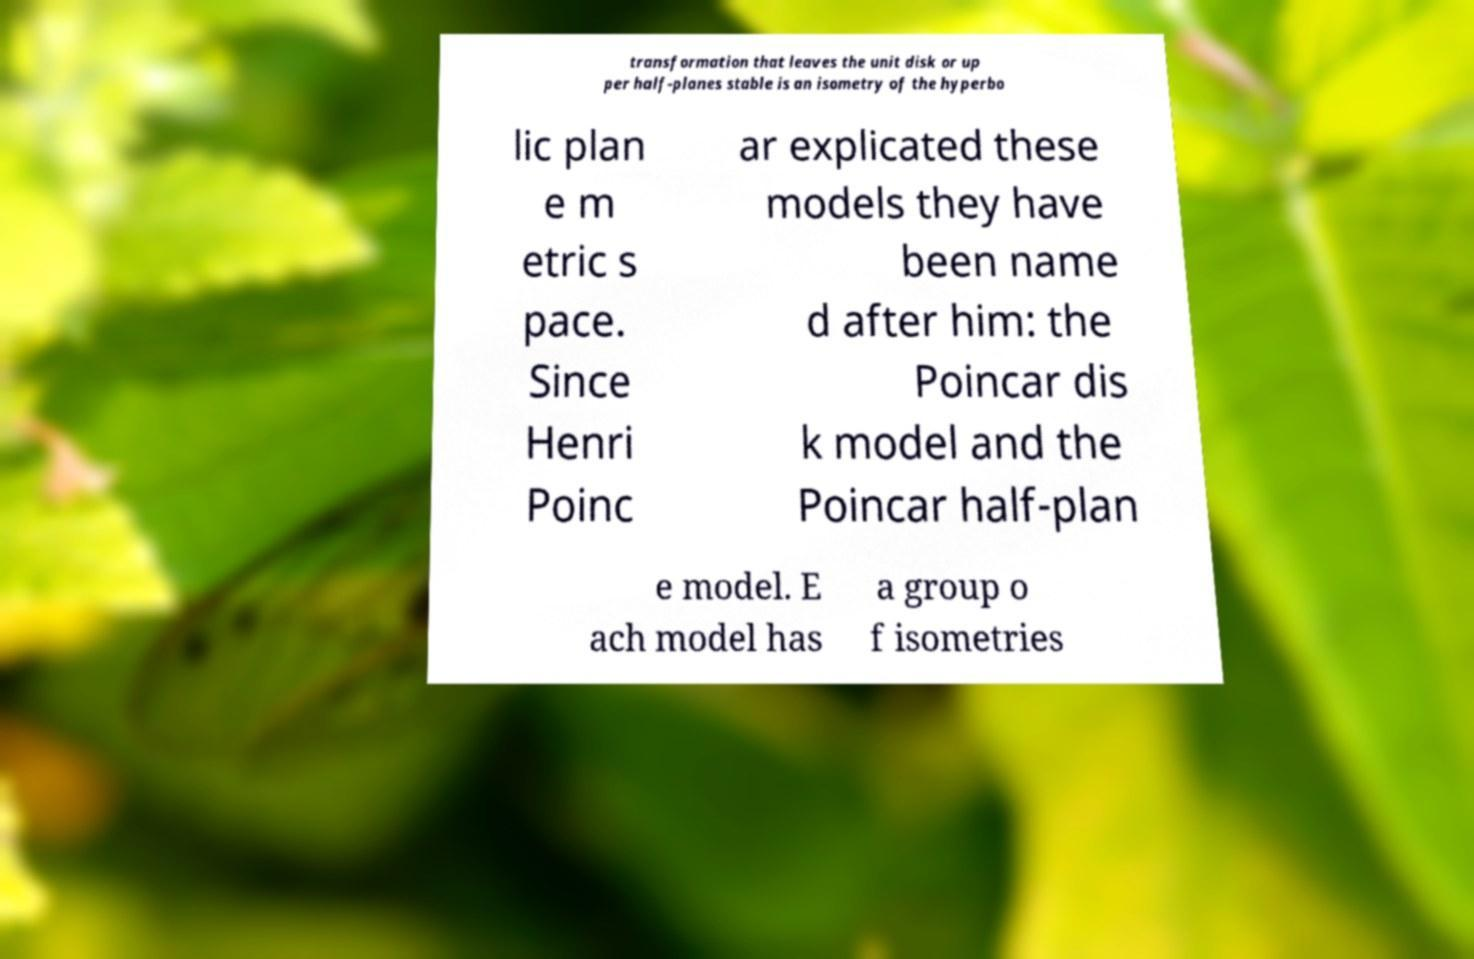I need the written content from this picture converted into text. Can you do that? transformation that leaves the unit disk or up per half-planes stable is an isometry of the hyperbo lic plan e m etric s pace. Since Henri Poinc ar explicated these models they have been name d after him: the Poincar dis k model and the Poincar half-plan e model. E ach model has a group o f isometries 